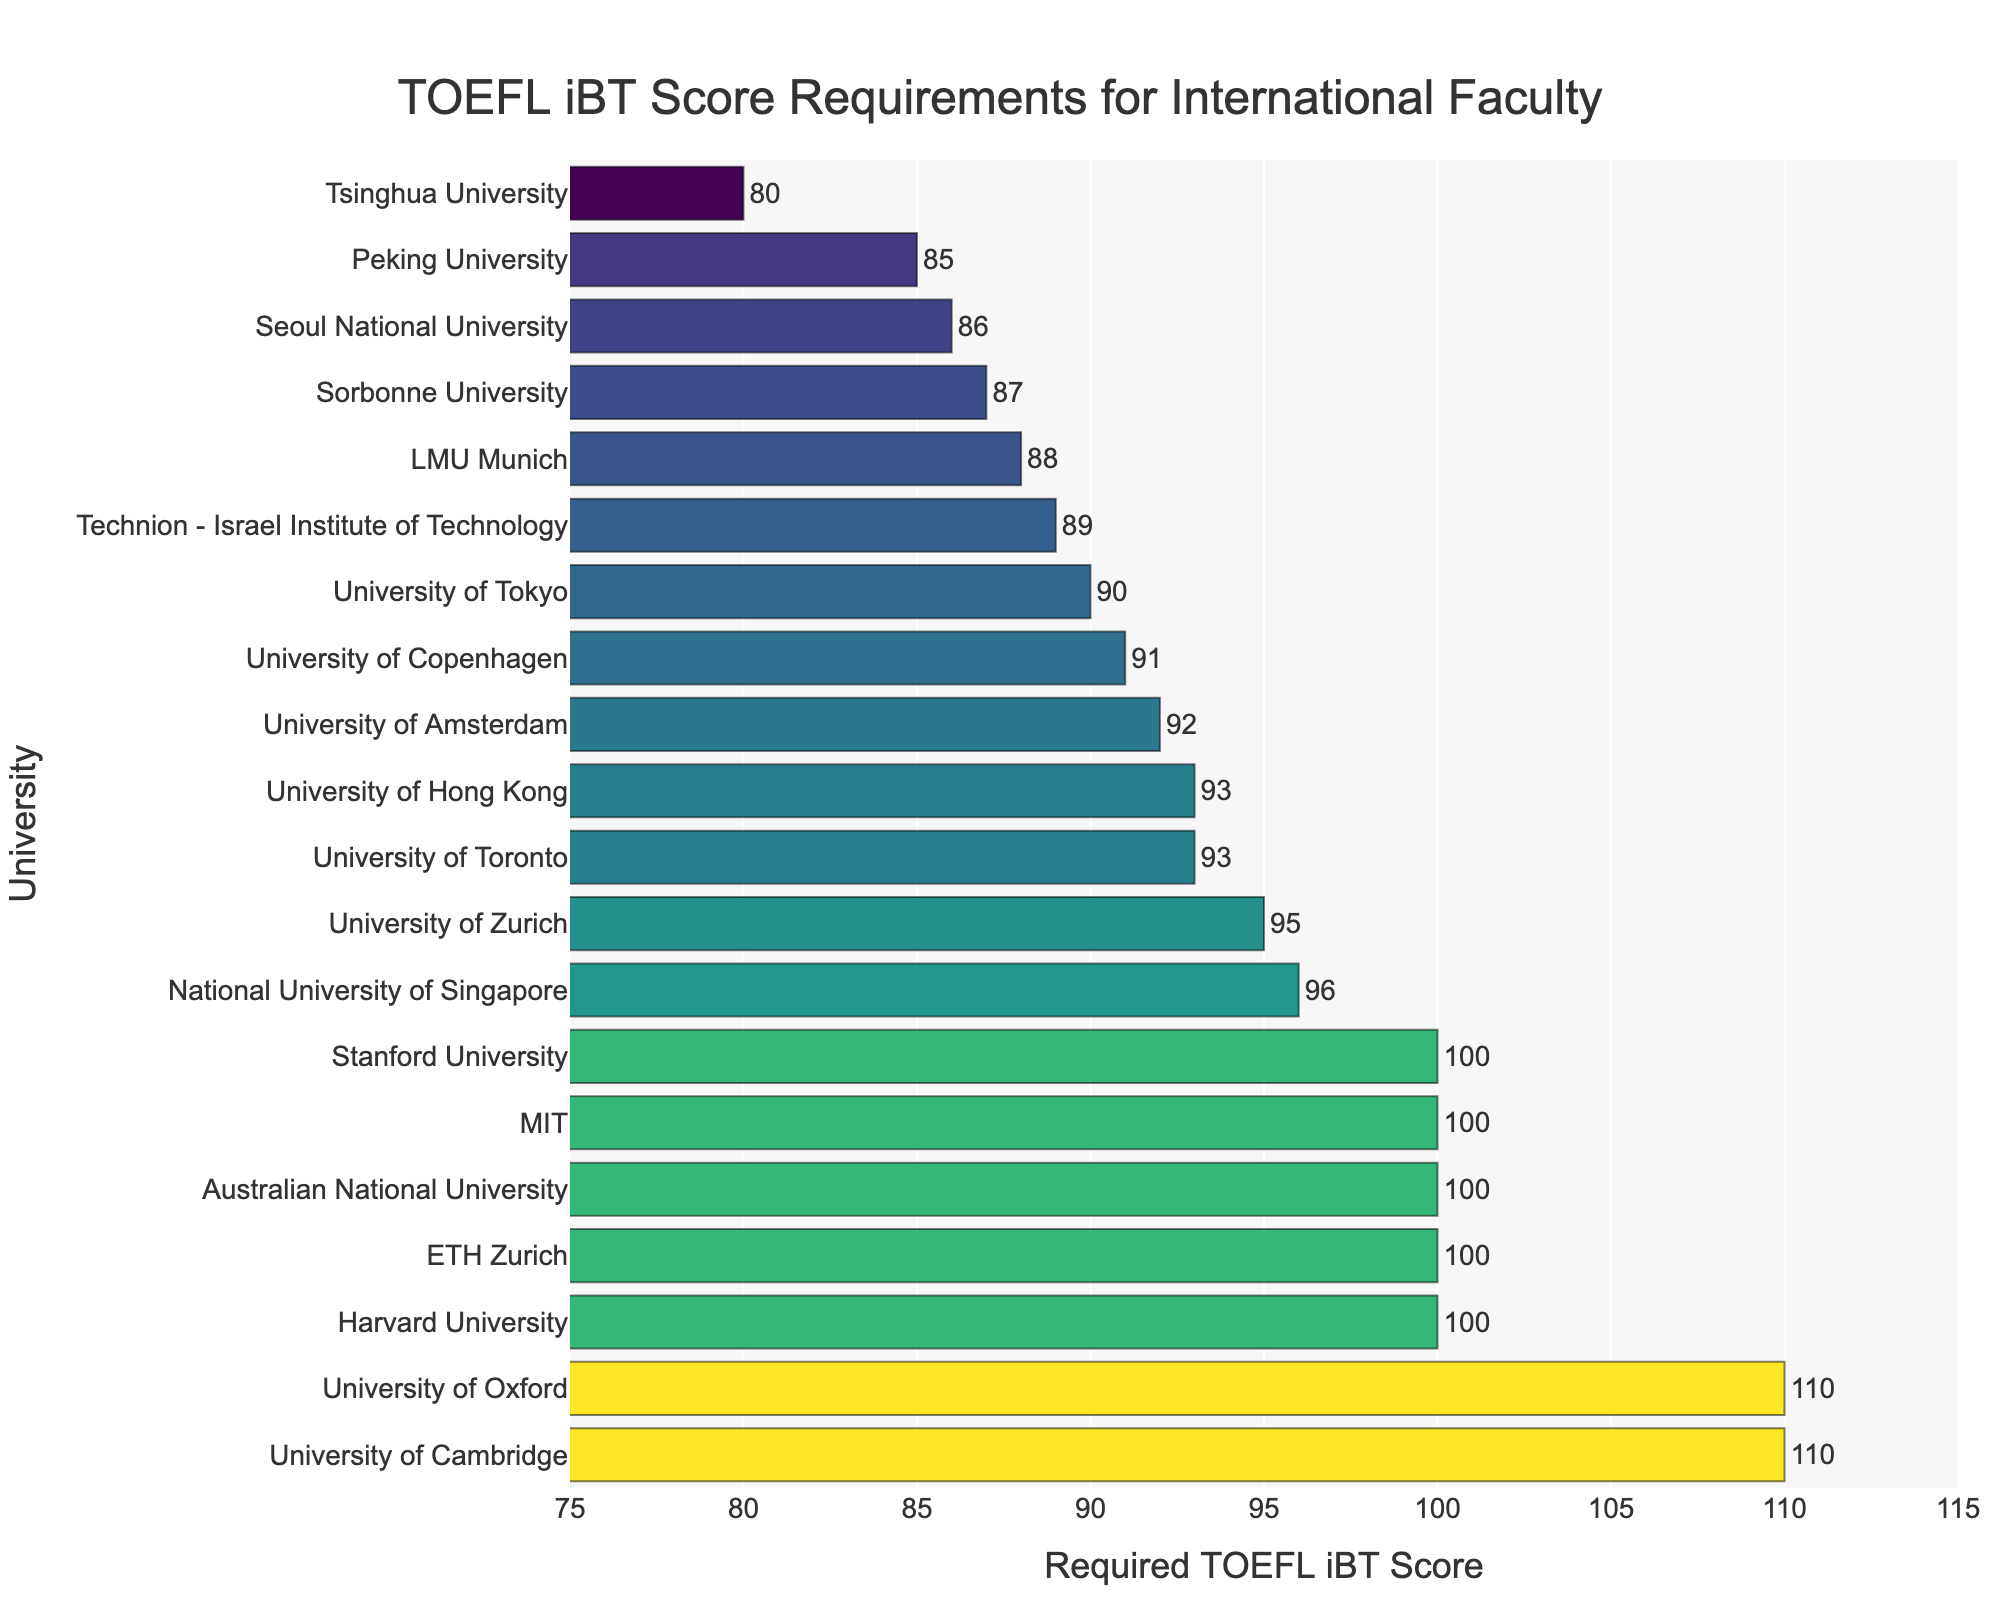Which university requires the highest TOEFL iBT score for international faculty? Harvard University and the University of Oxford require the highest TOEFL iBT scores as their bars are the highest and both show a score of 110.
Answer: Harvard University and the University of Oxford Which university requires the lowest TOEFL iBT score for international faculty? Tsinghua University's bar is the smallest, indicating the lowest TOEFL iBT score requirement, which is 80.
Answer: Tsinghua University What's the average TOEFL iBT score requirement across all listed universities? To find the average, sum all the TOEFL iBT scores and then divide by the number of universities: (100+110+100+100+110+100+96+90+85+93+100+88+87+91+92+86+80+93+89+95) / 20 = 1925 / 20 = 96.25.
Answer: 96.25 Which universities have a TOEFL iBT score requirement greater than or equal to 100? From the bars, Harvard University, University of Oxford, Stanford University, MIT, University of Cambridge, ETH Zurich, Australian National University, and University of Zurich all have TOEFL iBT scores of 100 or more.
Answer: Harvard University, University of Oxford, Stanford University, MIT, University of Cambridge, ETH Zurich, Australian National University, University of Zurich How many universities require a TOEFL iBT score of less than 90? By counting the bars, Peking University, LMU Munich, Sorbonne University, Seoul National University, and Tsinghua University require TOEFL iBT scores below 90.
Answer: Five Which university's TOEFL iBT score requirement is closest to the average of all universities listed? The average score is 96.25. The universities closest to this score are the National University of Singapore (96) and the University of Zurich (95).
Answer: National University of Singapore and University of Zurich Compare the TOEFL score requirement between University of Tokyo and University of Amsterdam. Which one is higher? By looking at the bars, University of Amsterdam requires a score of 92, which is higher than University of Tokyo's score of 90.
Answer: University of Amsterdam What is the total TOEFL iBT score for universities with a requirement higher than 100? From the bars, University of Oxford and University of Cambridge each have a TOEFL iBT score requirement of 110, so the total is 110 + 110 = 220.
Answer: 220 Do more universities require a TOEFL iBT score of 100 or 95? Looking at the bars, there are 6 universities with a TOEFL iBT score of 100, and 1 university with a TOEFL score of 95; thus, more universities require a score of 100.
Answer: 100 What is the difference in TOEFL iBT score requirements between the highest and lowest universities? The highest TOEFL requirement is 110 (Harvard, University of Oxford), and the lowest is 80 (Tsinghua University). The difference is 110 - 80 = 30.
Answer: 30 